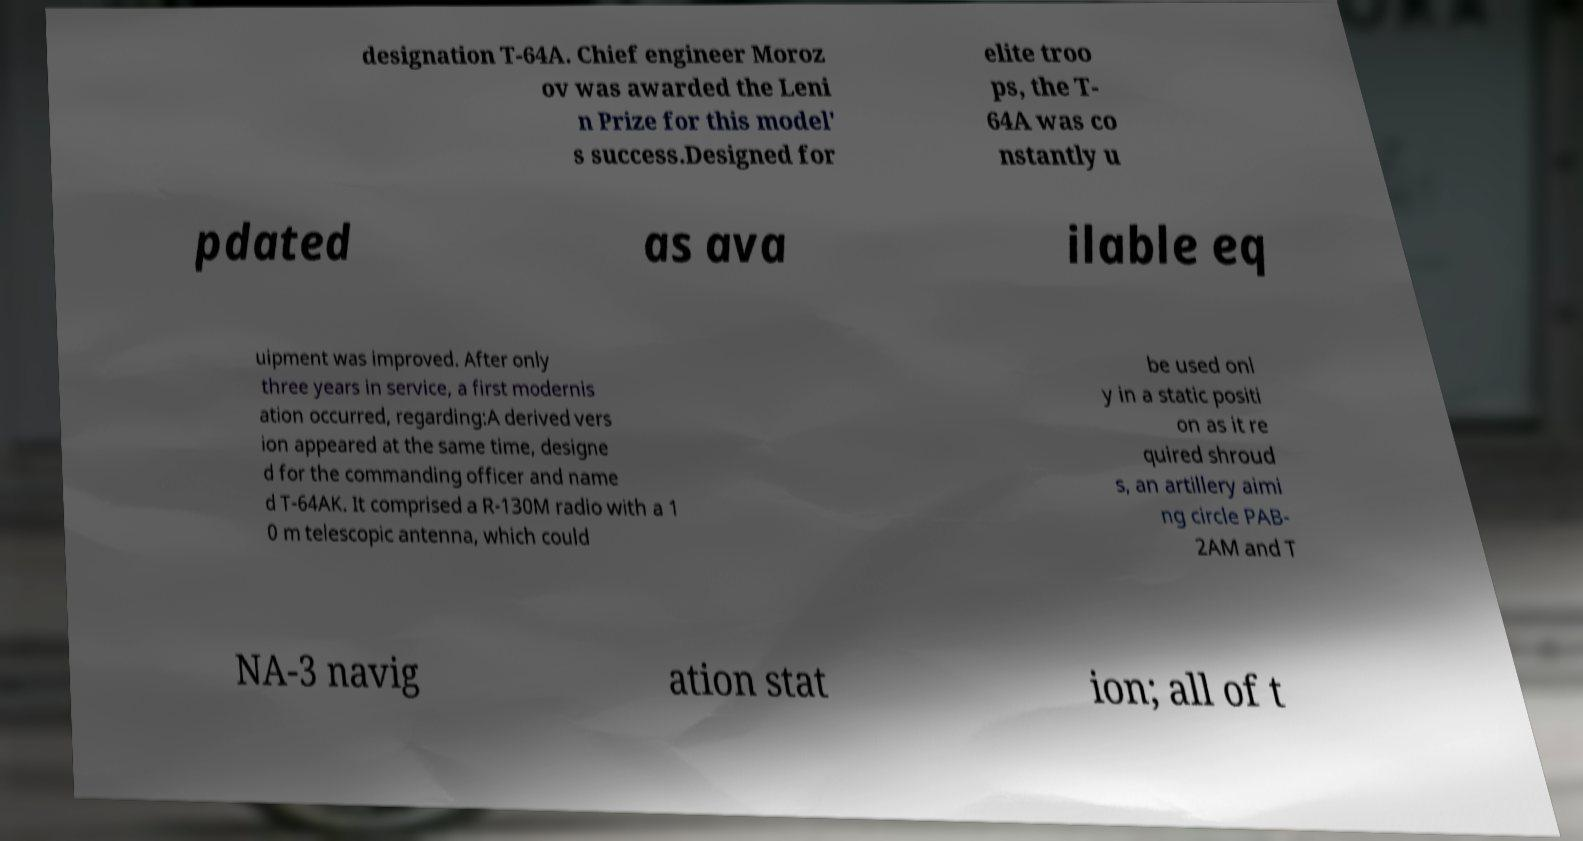I need the written content from this picture converted into text. Can you do that? designation T-64A. Chief engineer Moroz ov was awarded the Leni n Prize for this model' s success.Designed for elite troo ps, the T- 64A was co nstantly u pdated as ava ilable eq uipment was improved. After only three years in service, a first modernis ation occurred, regarding:A derived vers ion appeared at the same time, designe d for the commanding officer and name d T-64AK. It comprised a R-130M radio with a 1 0 m telescopic antenna, which could be used onl y in a static positi on as it re quired shroud s, an artillery aimi ng circle PAB- 2AM and T NA-3 navig ation stat ion; all of t 